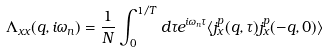Convert formula to latex. <formula><loc_0><loc_0><loc_500><loc_500>\Lambda _ { x x } ( { q } , i \omega _ { n } ) = \frac { 1 } { N } \int _ { 0 } ^ { 1 / T } d \tau e ^ { i \omega _ { n } \tau } \langle j _ { x } ^ { p } ( { q } , \tau ) j _ { x } ^ { p } ( - { q } , 0 ) \rangle</formula> 